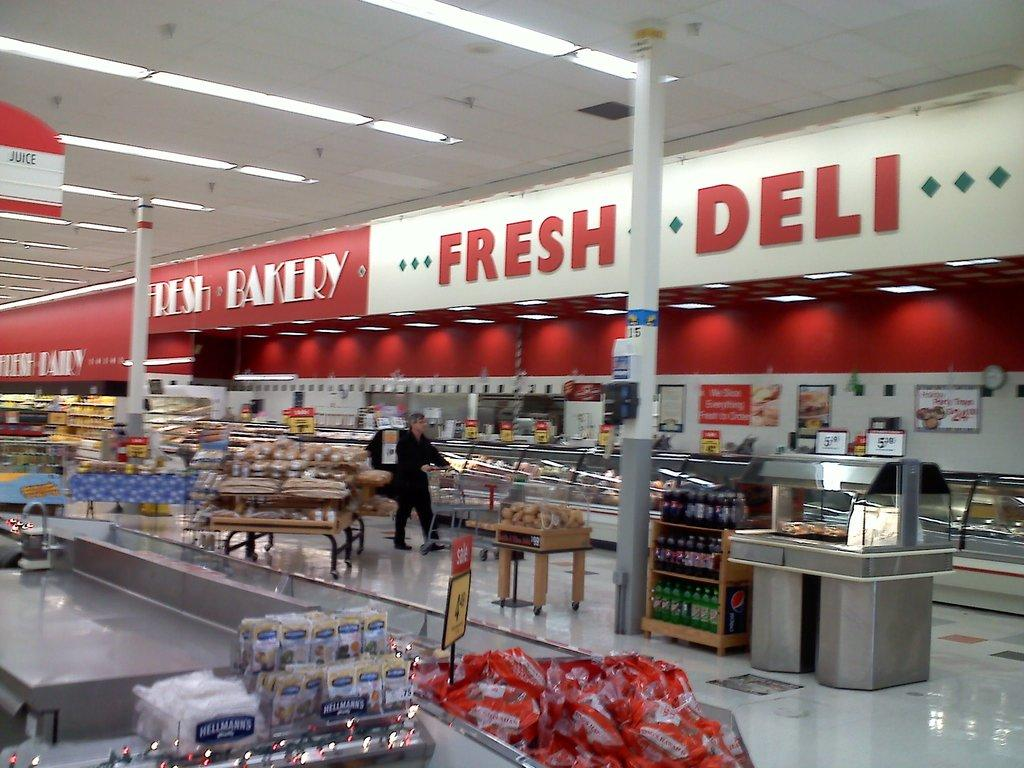Provide a one-sentence caption for the provided image. Fresh Deli and Fresh Bakery are written in opposing color schemes at this grocery store. 